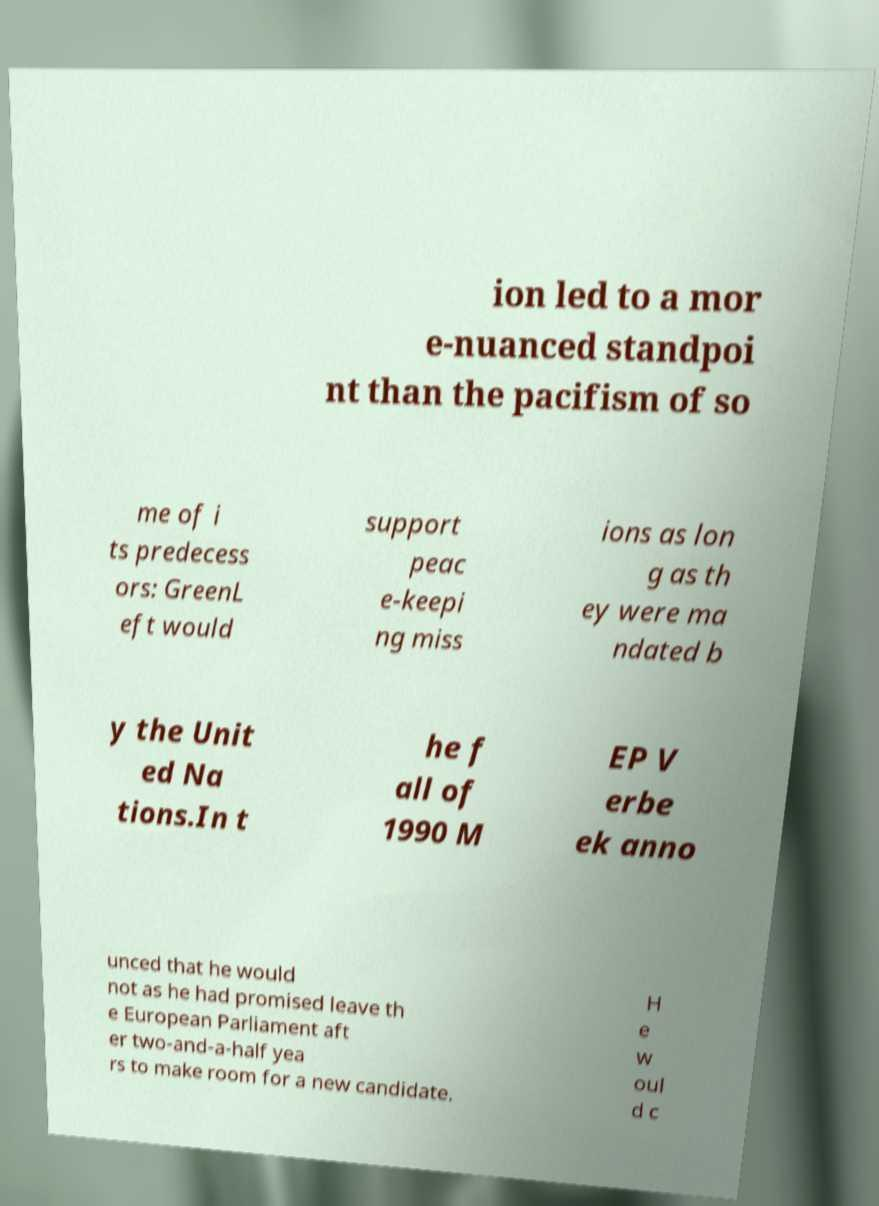Could you extract and type out the text from this image? ion led to a mor e-nuanced standpoi nt than the pacifism of so me of i ts predecess ors: GreenL eft would support peac e-keepi ng miss ions as lon g as th ey were ma ndated b y the Unit ed Na tions.In t he f all of 1990 M EP V erbe ek anno unced that he would not as he had promised leave th e European Parliament aft er two-and-a-half yea rs to make room for a new candidate. H e w oul d c 